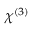Convert formula to latex. <formula><loc_0><loc_0><loc_500><loc_500>\chi ^ { ( 3 ) }</formula> 